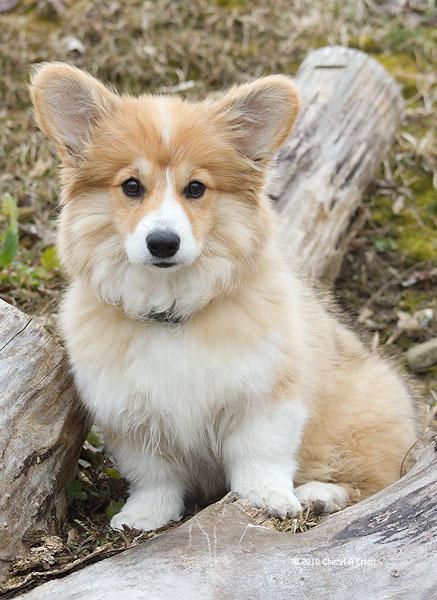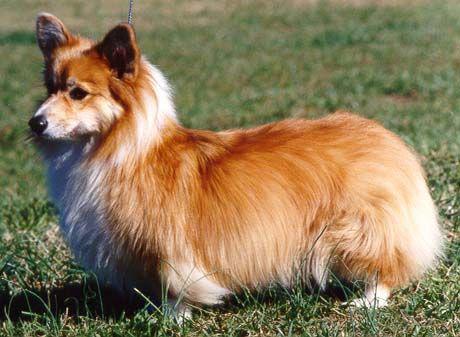The first image is the image on the left, the second image is the image on the right. Evaluate the accuracy of this statement regarding the images: "There are only two dogs and neither of them is wearing a hat.". Is it true? Answer yes or no. Yes. The first image is the image on the left, the second image is the image on the right. Given the left and right images, does the statement "At least one dog has it's mouth open." hold true? Answer yes or no. No. 